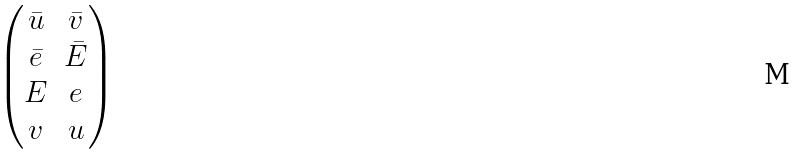Convert formula to latex. <formula><loc_0><loc_0><loc_500><loc_500>\begin{pmatrix} \bar { u } & \bar { v } \\ \bar { e } & \bar { E } \\ E & e \\ v & u \end{pmatrix}</formula> 